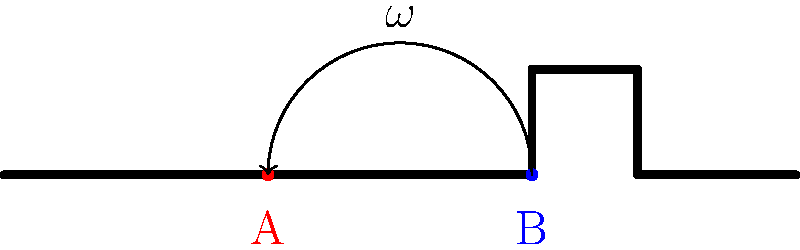A hockey stick is spinning with angular velocity $\omega$ about its center of mass. If a player grips the stick at point A instead of point B, how will the angular momentum of the stick change? Assume the mass of the stick is uniformly distributed. To solve this problem, we need to consider the relationship between angular momentum, moment of inertia, and the axis of rotation. Let's break it down step-by-step:

1) The angular momentum $L$ is given by $L = I\omega$, where $I$ is the moment of inertia and $\omega$ is the angular velocity.

2) The moment of inertia depends on the axis of rotation. For a uniform rod rotating about its center, $I = \frac{1}{12}ML^2$, where $M$ is the mass and $L$ is the length of the rod.

3) When the axis of rotation is moved from the center (point B) to point A:
   a) The new axis is no longer at the center of mass.
   b) We need to use the parallel axis theorem: $I_A = I_{CM} + Md^2$, where $d$ is the distance from the center of mass to the new axis.

4) The distance $d$ is half the distance between points A and B, which is about 1/4 of the stick's length. So, $d = L/4$.

5) Therefore, the new moment of inertia is:
   $I_A = \frac{1}{12}ML^2 + M(\frac{L}{4})^2 = \frac{1}{12}ML^2 + \frac{1}{16}ML^2 = \frac{7}{48}ML^2$

6) The new angular momentum is:
   $L_A = I_A\omega = \frac{7}{48}ML^2\omega$

7) Compared to the original angular momentum:
   $L_B = I_B\omega = \frac{1}{12}ML^2\omega$

8) The ratio of the new to the original angular momentum is:
   $\frac{L_A}{L_B} = \frac{\frac{7}{48}ML^2\omega}{\frac{1}{12}ML^2\omega} = \frac{7}{4} = 1.75$

Therefore, the angular momentum increases by a factor of 1.75 or 75% when gripped at point A instead of point B.
Answer: The angular momentum increases by 75%. 